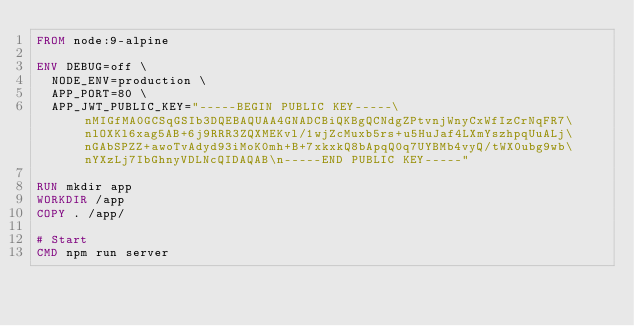<code> <loc_0><loc_0><loc_500><loc_500><_Dockerfile_>FROM node:9-alpine

ENV DEBUG=off \
  NODE_ENV=production \
  APP_PORT=80 \
  APP_JWT_PUBLIC_KEY="-----BEGIN PUBLIC KEY-----\nMIGfMA0GCSqGSIb3DQEBAQUAA4GNADCBiQKBgQCNdgZPtvnjWnyCxWfIzCrNqFR7\nlOXKl6xag5AB+6j9RRR3ZQXMEKvl/1wjZcMuxb5rs+u5HuJaf4LXmYszhpqUuALj\nGAbSPZZ+awoTvAdyd93iMoK0mh+B+7xkxkQ8bApqQ0q7UYBMb4vyQ/tWX0ubg9wb\nYXzLj7IbGhnyVDLNcQIDAQAB\n-----END PUBLIC KEY-----"

RUN mkdir app
WORKDIR /app
COPY . /app/

# Start
CMD npm run server</code> 